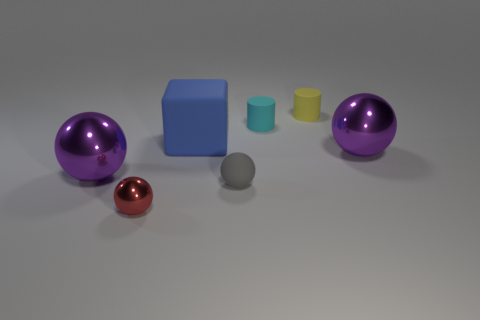Can you tell me about the materials of the objects displayed in the image? Certainly! In the image, we see objects that appear to be made from various materials. The two large shiny spheres look metallic, with one having a purple hue and the other a chromatic finish. The cube and the cylinders seem to be made of rubber or plastic since they have a matte texture and less reflective surface. Finally, the tiny gray object in the middle appears to be a small stone or a piece of clay, due to its muted color and texture. 